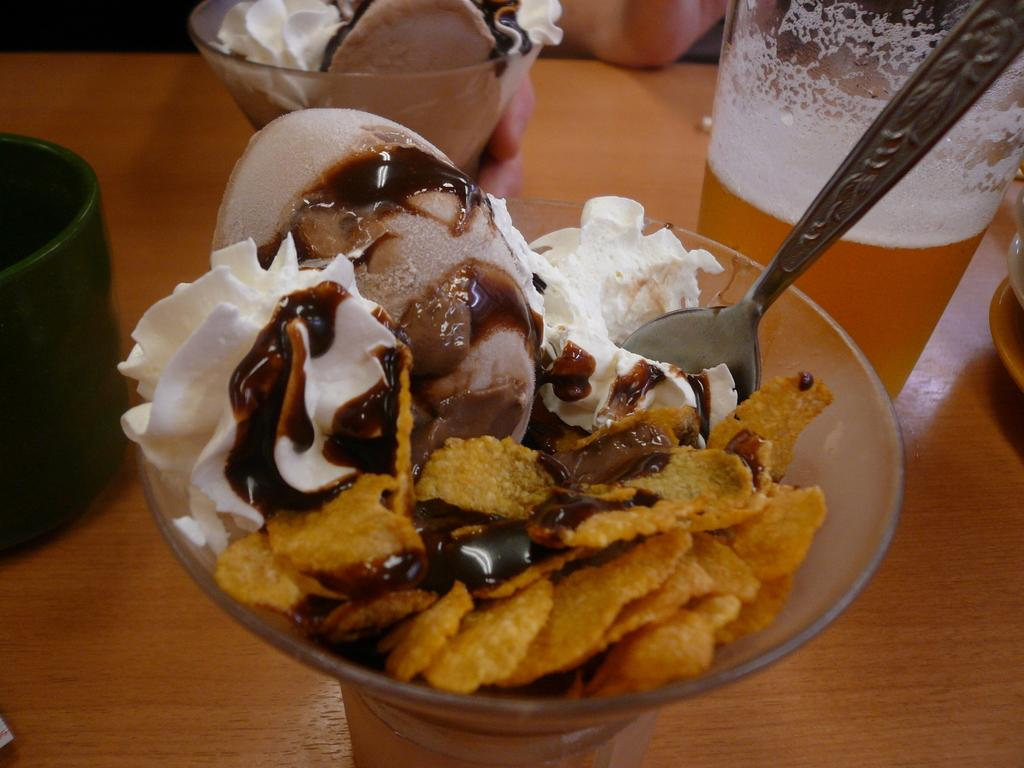What type of ice cream is in the cup in the image? There is an ice cream with chips in a cup in the image. What utensil is present in the ice cream cup? A spoon is present in the cup. Where is the ice cream cup located? The cup is on a table. What is beside the ice cream cup on the table? There is a glass of juice beside the ice cream cup. Can you describe another ice cream-related item in the image? There is another ice cream cup with a plate in the image. What type of sweater is the ice cream wearing in the image? The ice cream is not wearing a sweater, as it is an inanimate object and cannot wear clothing. 